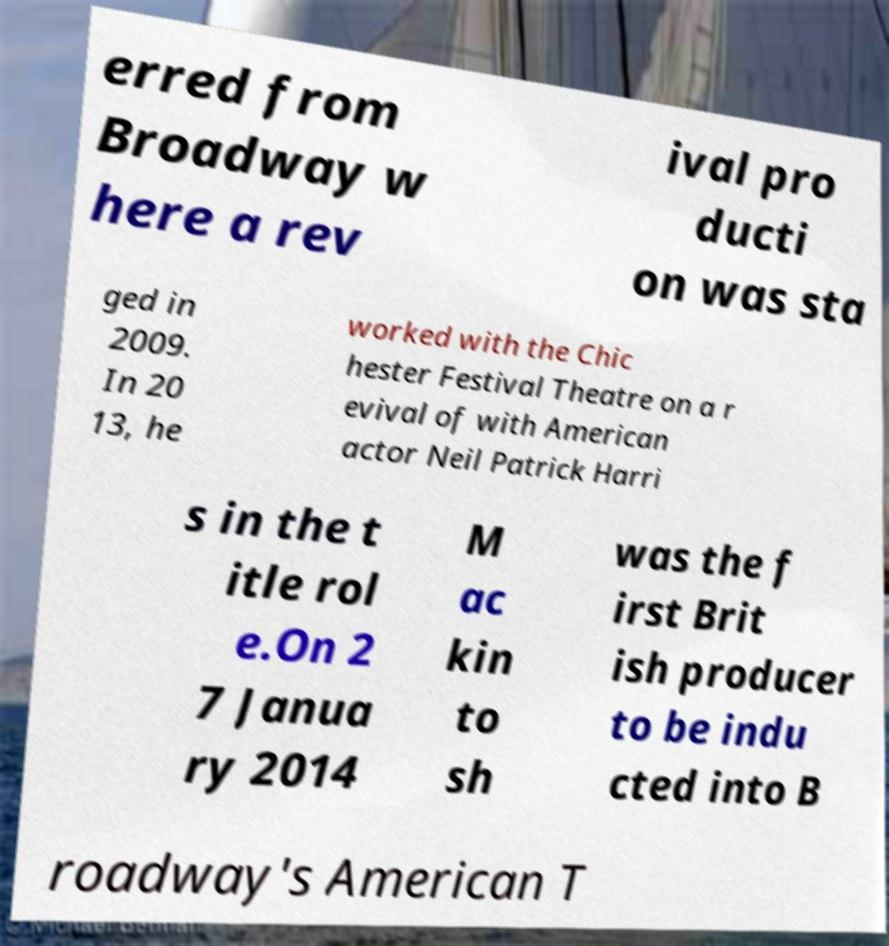Could you extract and type out the text from this image? erred from Broadway w here a rev ival pro ducti on was sta ged in 2009. In 20 13, he worked with the Chic hester Festival Theatre on a r evival of with American actor Neil Patrick Harri s in the t itle rol e.On 2 7 Janua ry 2014 M ac kin to sh was the f irst Brit ish producer to be indu cted into B roadway's American T 